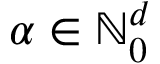Convert formula to latex. <formula><loc_0><loc_0><loc_500><loc_500>{ \alpha } \in { \mathbb { N } } _ { 0 } ^ { d }</formula> 